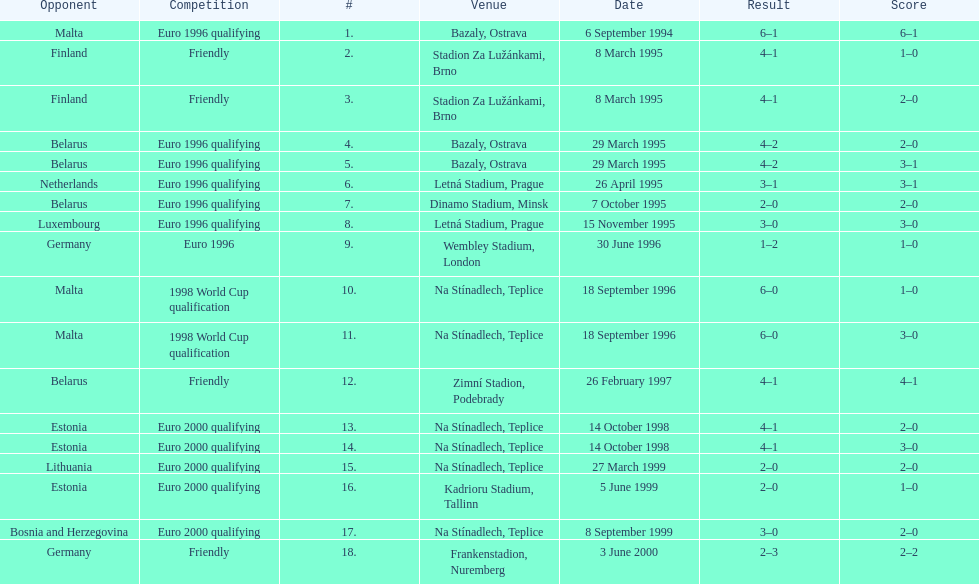How many euro 2000 qualifying competitions are listed? 4. 